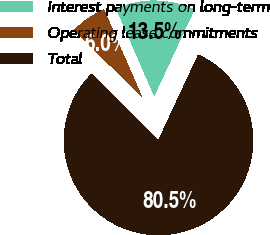<chart> <loc_0><loc_0><loc_500><loc_500><pie_chart><fcel>Interest payments on long-term<fcel>Operating lease commitments<fcel>Total<nl><fcel>13.47%<fcel>6.02%<fcel>80.52%<nl></chart> 